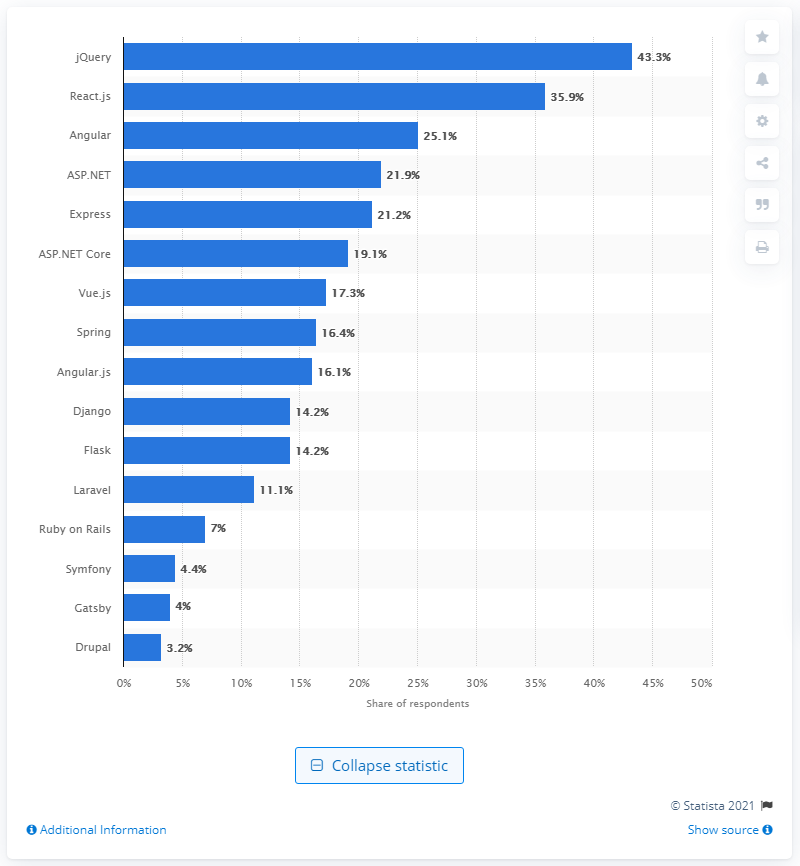jQuery has been losing ground to React.js and what other framework? Alongside React.js, Angular is another prominent framework that has been gaining preference over jQuery among developers, as indicated by its significant share of respondents. 